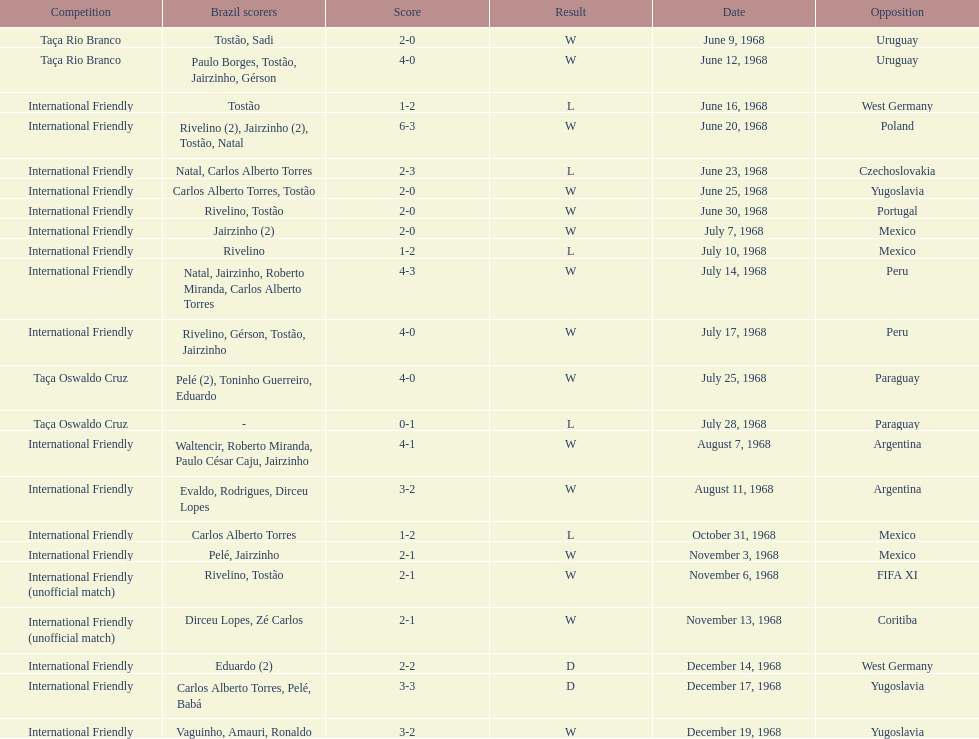Number of losses 5. 